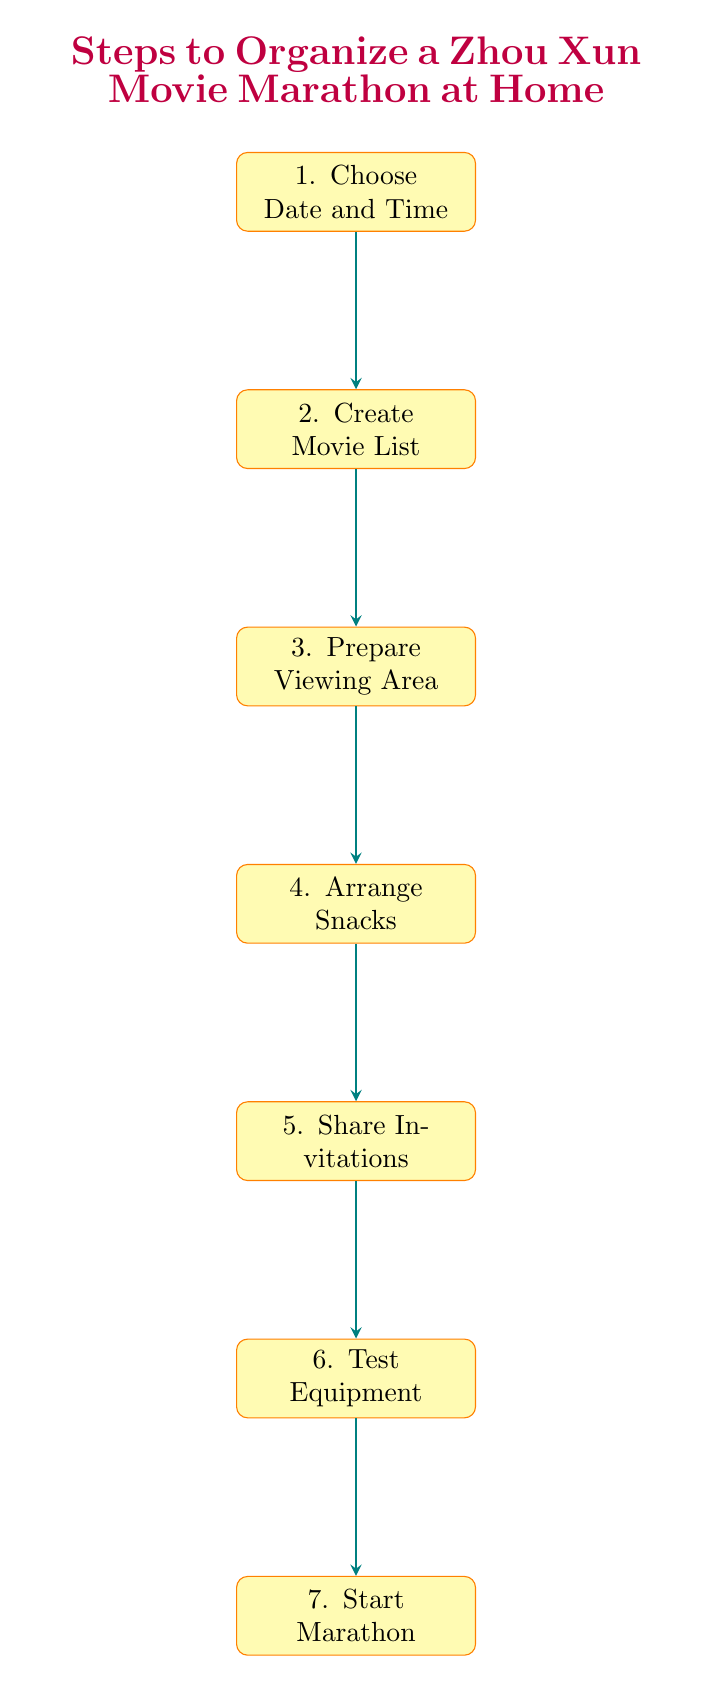What is the last step in organizing the movie marathon? The last step in the flow chart is "Start Marathon," which is directly linked to the second-to-last step "Test Equipment."
Answer: Start Marathon How many nodes are in the diagram? The diagram contains seven distinct nodes, each representing a step in the process of organizing the movie marathon.
Answer: 7 What step comes after "Prepare Viewing Area"? According to the flow of the diagram, the step that follows "Prepare Viewing Area" is "Arrange Snacks," indicating the next action to take in the sequence.
Answer: Arrange Snacks Which step involves sending invites to friends? The step that involves sharing invitations with friends is labeled "Share Invitations," which is clearly indicated in the arrangement of the nodes.
Answer: Share Invitations What two steps are directly connected before starting the marathon? The two steps directly connected before starting the marathon are "Test Equipment" and "Start Marathon," forming a sequential relationship leading up to the event.
Answer: Test Equipment, Start Marathon What is the immediate action after "Create Movie List"? The immediate action after "Create Movie List" is to "Prepare Viewing Area," showing the progression from selecting movies to setting up the viewing space.
Answer: Prepare Viewing Area How are the steps related in terms of sequence? The steps in the diagram are related in a sequential manner, where each step leads to the next, starting from choosing a date and time down to starting the marathon.
Answer: Sequentially 